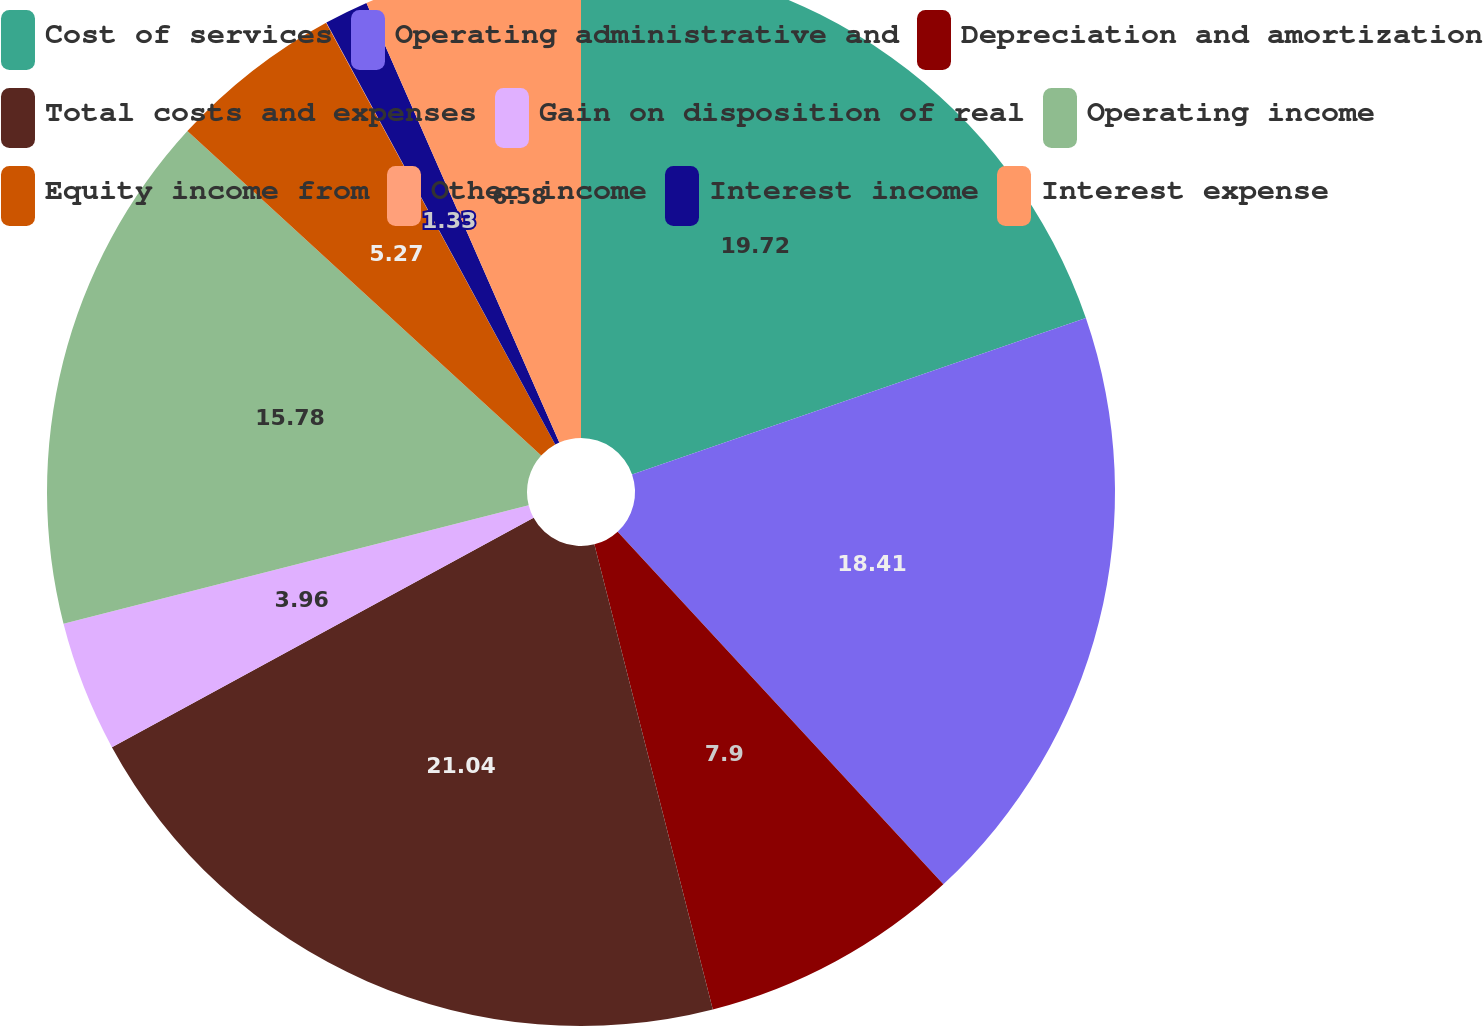<chart> <loc_0><loc_0><loc_500><loc_500><pie_chart><fcel>Cost of services<fcel>Operating administrative and<fcel>Depreciation and amortization<fcel>Total costs and expenses<fcel>Gain on disposition of real<fcel>Operating income<fcel>Equity income from<fcel>Other income<fcel>Interest income<fcel>Interest expense<nl><fcel>19.72%<fcel>18.41%<fcel>7.9%<fcel>21.04%<fcel>3.96%<fcel>15.78%<fcel>5.27%<fcel>0.01%<fcel>1.33%<fcel>6.58%<nl></chart> 